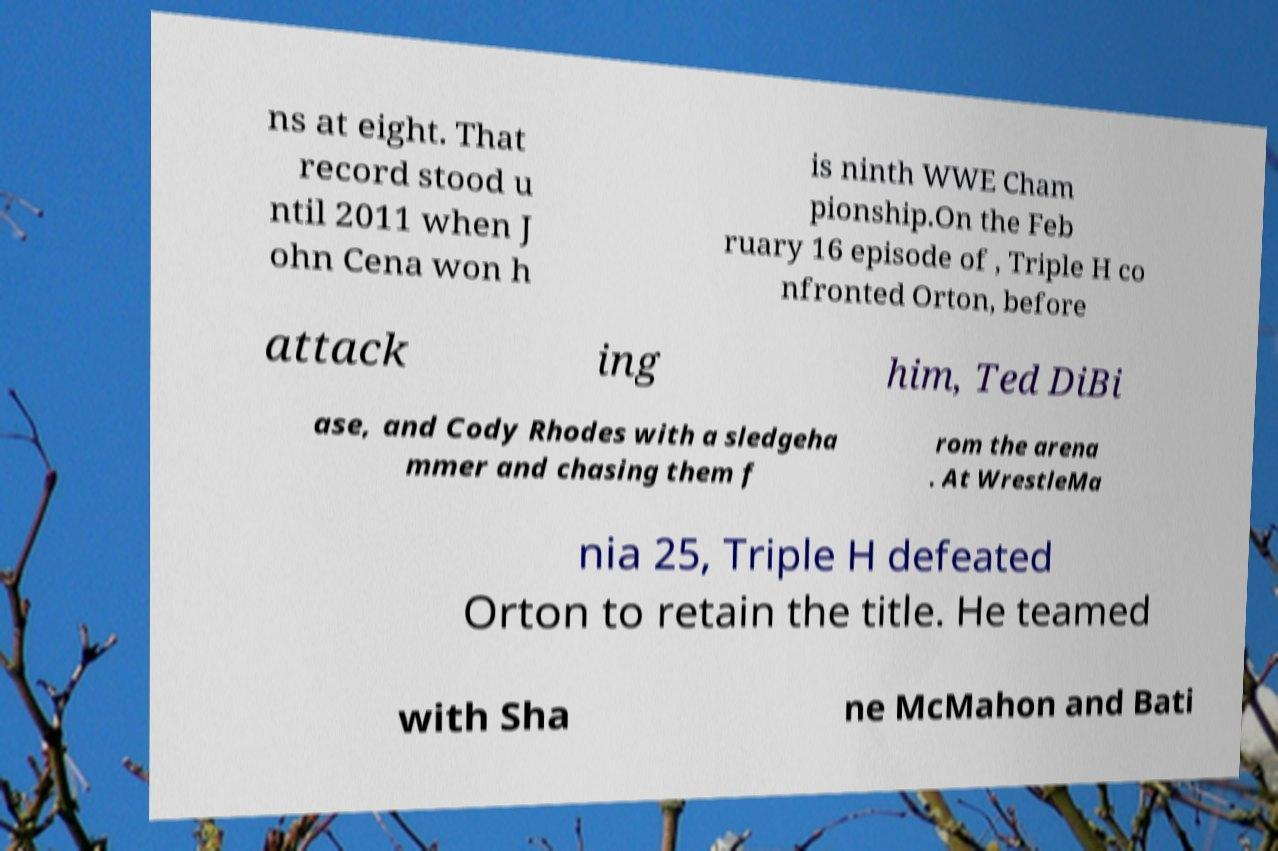Could you extract and type out the text from this image? ns at eight. That record stood u ntil 2011 when J ohn Cena won h is ninth WWE Cham pionship.On the Feb ruary 16 episode of , Triple H co nfronted Orton, before attack ing him, Ted DiBi ase, and Cody Rhodes with a sledgeha mmer and chasing them f rom the arena . At WrestleMa nia 25, Triple H defeated Orton to retain the title. He teamed with Sha ne McMahon and Bati 